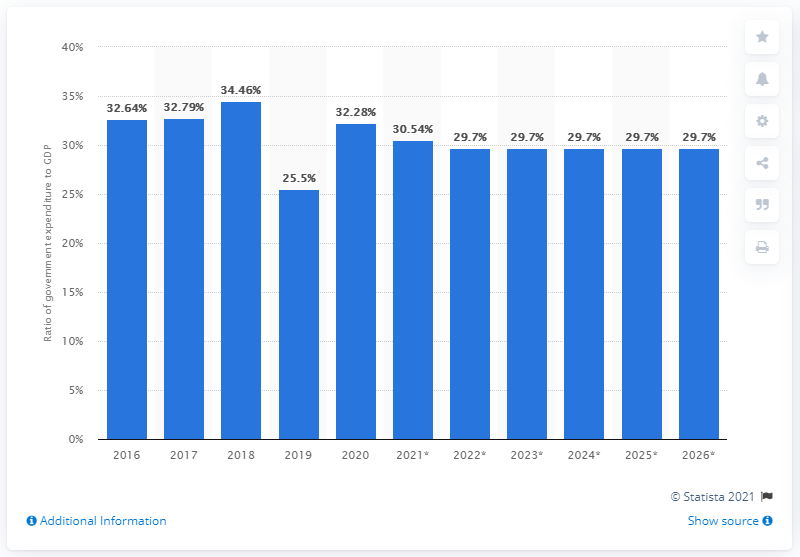Give some essential details in this illustration. In 2020, government expenditure in Bhutan accounted for 32.28% of the country's Gross Domestic Product (GDP). 